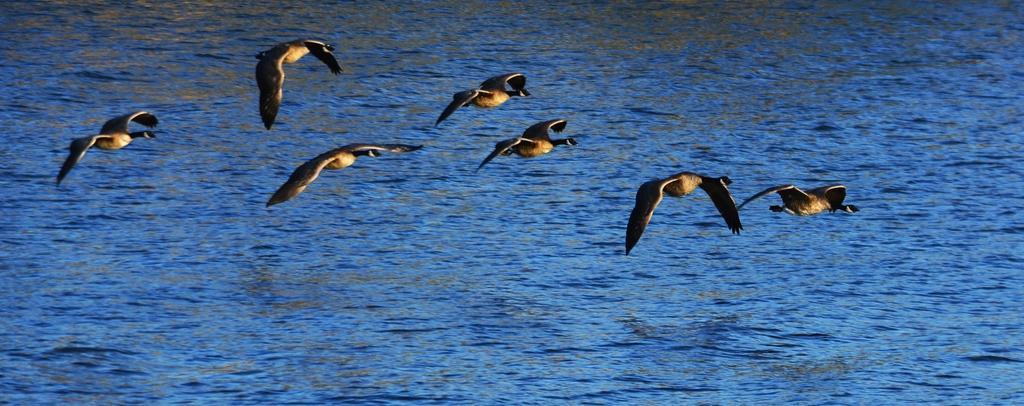Please provide a concise description of this image. In this image there are some birds as we can see in middle of this image and there is a Sea in the background. 